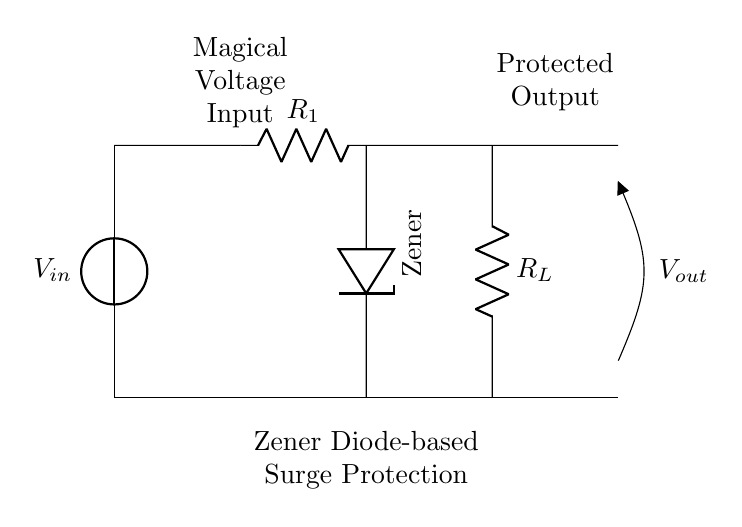What is the input voltage source labeled as? The input voltage source is labeled as "V_in" at the top of the circuit diagram. It indicates where the voltage supply enters the circuit.
Answer: V_in What is the resistance value of the current limiting resistor? The current limiting resistor is labeled "R_1" in the circuit diagram. However, the exact resistance value is not provided visually in this document.
Answer: R_1 What component is used for voltage regulation in this circuit? The component used for voltage regulation in this circuit is the Zener diode, indicated as "Zener" in the diagram. Zener diodes are commonly used to maintain a constant voltage across components.
Answer: Zener What component is connected to the output labeled as "V_out"? The component connected to the output labeled "V_out" is the load resistor represented as "R_L" in the diagram. This resistor represents the load that will receive the regulated voltage.
Answer: R_L What is the purpose of the Zener diode in this circuit? The Zener diode is utilized for voltage regulation and surge protection. It allows current to flow in the reverse direction when the voltage exceeds a certain value (Zener breakdown voltage), which protects the rest of the circuit from voltage spikes.
Answer: Surge protection How does the Zener diode protect against voltage surges? The Zener diode protects against voltage surges by conducting current in reverse when the input voltage exceeds its breakdown voltage, thus clamping the output voltage to a predefined level and preventing overvoltage conditions in the load. This ensures that sensitive components downstream are not harmed.
Answer: By clamping voltage What happens to the output voltage when the input voltage exceeds the breakdown voltage of the Zener diode? When the input voltage exceeds the breakdown voltage of the Zener diode, the Zener diode conducts, and the output voltage remains constant at the Zener voltage despite increases in input voltage, effectively stabilizing the output voltage.
Answer: Output voltage stabilizes 